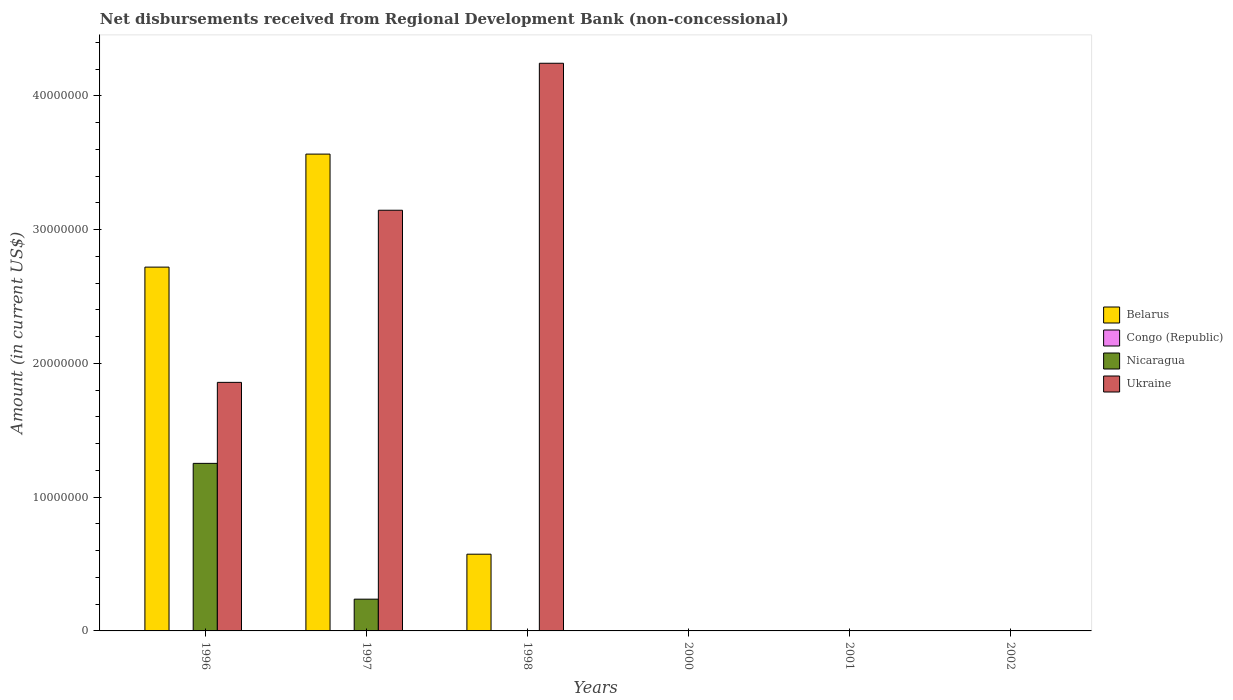How many different coloured bars are there?
Make the answer very short. 3. Are the number of bars on each tick of the X-axis equal?
Your response must be concise. No. How many bars are there on the 5th tick from the left?
Your answer should be compact. 0. What is the label of the 5th group of bars from the left?
Make the answer very short. 2001. What is the amount of disbursements received from Regional Development Bank in Nicaragua in 1996?
Keep it short and to the point. 1.25e+07. Across all years, what is the maximum amount of disbursements received from Regional Development Bank in Ukraine?
Provide a short and direct response. 4.24e+07. Across all years, what is the minimum amount of disbursements received from Regional Development Bank in Nicaragua?
Make the answer very short. 0. In which year was the amount of disbursements received from Regional Development Bank in Belarus maximum?
Give a very brief answer. 1997. What is the total amount of disbursements received from Regional Development Bank in Congo (Republic) in the graph?
Provide a succinct answer. 0. What is the difference between the amount of disbursements received from Regional Development Bank in Nicaragua in 2001 and the amount of disbursements received from Regional Development Bank in Ukraine in 1996?
Ensure brevity in your answer.  -1.86e+07. What is the average amount of disbursements received from Regional Development Bank in Ukraine per year?
Your response must be concise. 1.54e+07. In the year 1997, what is the difference between the amount of disbursements received from Regional Development Bank in Ukraine and amount of disbursements received from Regional Development Bank in Nicaragua?
Ensure brevity in your answer.  2.91e+07. What is the difference between the highest and the second highest amount of disbursements received from Regional Development Bank in Belarus?
Keep it short and to the point. 8.45e+06. What is the difference between the highest and the lowest amount of disbursements received from Regional Development Bank in Nicaragua?
Make the answer very short. 1.25e+07. Is it the case that in every year, the sum of the amount of disbursements received from Regional Development Bank in Ukraine and amount of disbursements received from Regional Development Bank in Congo (Republic) is greater than the amount of disbursements received from Regional Development Bank in Nicaragua?
Your answer should be very brief. No. Are all the bars in the graph horizontal?
Provide a succinct answer. No. How many years are there in the graph?
Your answer should be very brief. 6. Are the values on the major ticks of Y-axis written in scientific E-notation?
Provide a short and direct response. No. Does the graph contain any zero values?
Your answer should be very brief. Yes. Where does the legend appear in the graph?
Provide a succinct answer. Center right. How many legend labels are there?
Make the answer very short. 4. What is the title of the graph?
Your answer should be compact. Net disbursements received from Regional Development Bank (non-concessional). Does "Honduras" appear as one of the legend labels in the graph?
Keep it short and to the point. No. What is the label or title of the X-axis?
Give a very brief answer. Years. What is the label or title of the Y-axis?
Offer a terse response. Amount (in current US$). What is the Amount (in current US$) in Belarus in 1996?
Offer a very short reply. 2.72e+07. What is the Amount (in current US$) of Congo (Republic) in 1996?
Your answer should be compact. 0. What is the Amount (in current US$) in Nicaragua in 1996?
Keep it short and to the point. 1.25e+07. What is the Amount (in current US$) of Ukraine in 1996?
Your answer should be compact. 1.86e+07. What is the Amount (in current US$) in Belarus in 1997?
Your answer should be very brief. 3.56e+07. What is the Amount (in current US$) in Nicaragua in 1997?
Give a very brief answer. 2.37e+06. What is the Amount (in current US$) in Ukraine in 1997?
Your answer should be compact. 3.15e+07. What is the Amount (in current US$) in Belarus in 1998?
Your answer should be very brief. 5.74e+06. What is the Amount (in current US$) in Nicaragua in 1998?
Provide a short and direct response. 0. What is the Amount (in current US$) in Ukraine in 1998?
Keep it short and to the point. 4.24e+07. What is the Amount (in current US$) in Belarus in 2000?
Keep it short and to the point. 0. What is the Amount (in current US$) of Nicaragua in 2000?
Offer a very short reply. 0. What is the Amount (in current US$) in Congo (Republic) in 2001?
Give a very brief answer. 0. What is the Amount (in current US$) in Nicaragua in 2001?
Provide a succinct answer. 0. What is the Amount (in current US$) in Congo (Republic) in 2002?
Offer a very short reply. 0. What is the Amount (in current US$) in Ukraine in 2002?
Provide a succinct answer. 0. Across all years, what is the maximum Amount (in current US$) of Belarus?
Provide a succinct answer. 3.56e+07. Across all years, what is the maximum Amount (in current US$) in Nicaragua?
Give a very brief answer. 1.25e+07. Across all years, what is the maximum Amount (in current US$) of Ukraine?
Your response must be concise. 4.24e+07. Across all years, what is the minimum Amount (in current US$) in Nicaragua?
Your response must be concise. 0. Across all years, what is the minimum Amount (in current US$) in Ukraine?
Make the answer very short. 0. What is the total Amount (in current US$) in Belarus in the graph?
Your response must be concise. 6.86e+07. What is the total Amount (in current US$) in Nicaragua in the graph?
Give a very brief answer. 1.49e+07. What is the total Amount (in current US$) in Ukraine in the graph?
Your response must be concise. 9.25e+07. What is the difference between the Amount (in current US$) of Belarus in 1996 and that in 1997?
Offer a very short reply. -8.45e+06. What is the difference between the Amount (in current US$) in Nicaragua in 1996 and that in 1997?
Ensure brevity in your answer.  1.02e+07. What is the difference between the Amount (in current US$) of Ukraine in 1996 and that in 1997?
Give a very brief answer. -1.29e+07. What is the difference between the Amount (in current US$) of Belarus in 1996 and that in 1998?
Provide a succinct answer. 2.15e+07. What is the difference between the Amount (in current US$) in Ukraine in 1996 and that in 1998?
Keep it short and to the point. -2.39e+07. What is the difference between the Amount (in current US$) of Belarus in 1997 and that in 1998?
Ensure brevity in your answer.  2.99e+07. What is the difference between the Amount (in current US$) of Ukraine in 1997 and that in 1998?
Give a very brief answer. -1.10e+07. What is the difference between the Amount (in current US$) of Belarus in 1996 and the Amount (in current US$) of Nicaragua in 1997?
Offer a very short reply. 2.48e+07. What is the difference between the Amount (in current US$) in Belarus in 1996 and the Amount (in current US$) in Ukraine in 1997?
Keep it short and to the point. -4.25e+06. What is the difference between the Amount (in current US$) of Nicaragua in 1996 and the Amount (in current US$) of Ukraine in 1997?
Offer a very short reply. -1.89e+07. What is the difference between the Amount (in current US$) of Belarus in 1996 and the Amount (in current US$) of Ukraine in 1998?
Offer a very short reply. -1.52e+07. What is the difference between the Amount (in current US$) of Nicaragua in 1996 and the Amount (in current US$) of Ukraine in 1998?
Offer a terse response. -2.99e+07. What is the difference between the Amount (in current US$) of Belarus in 1997 and the Amount (in current US$) of Ukraine in 1998?
Ensure brevity in your answer.  -6.79e+06. What is the difference between the Amount (in current US$) in Nicaragua in 1997 and the Amount (in current US$) in Ukraine in 1998?
Offer a terse response. -4.01e+07. What is the average Amount (in current US$) in Belarus per year?
Give a very brief answer. 1.14e+07. What is the average Amount (in current US$) in Congo (Republic) per year?
Your answer should be very brief. 0. What is the average Amount (in current US$) in Nicaragua per year?
Keep it short and to the point. 2.48e+06. What is the average Amount (in current US$) in Ukraine per year?
Keep it short and to the point. 1.54e+07. In the year 1996, what is the difference between the Amount (in current US$) in Belarus and Amount (in current US$) in Nicaragua?
Provide a short and direct response. 1.47e+07. In the year 1996, what is the difference between the Amount (in current US$) in Belarus and Amount (in current US$) in Ukraine?
Ensure brevity in your answer.  8.62e+06. In the year 1996, what is the difference between the Amount (in current US$) of Nicaragua and Amount (in current US$) of Ukraine?
Give a very brief answer. -6.06e+06. In the year 1997, what is the difference between the Amount (in current US$) of Belarus and Amount (in current US$) of Nicaragua?
Offer a very short reply. 3.33e+07. In the year 1997, what is the difference between the Amount (in current US$) of Belarus and Amount (in current US$) of Ukraine?
Make the answer very short. 4.20e+06. In the year 1997, what is the difference between the Amount (in current US$) in Nicaragua and Amount (in current US$) in Ukraine?
Provide a short and direct response. -2.91e+07. In the year 1998, what is the difference between the Amount (in current US$) in Belarus and Amount (in current US$) in Ukraine?
Your response must be concise. -3.67e+07. What is the ratio of the Amount (in current US$) in Belarus in 1996 to that in 1997?
Keep it short and to the point. 0.76. What is the ratio of the Amount (in current US$) in Nicaragua in 1996 to that in 1997?
Provide a succinct answer. 5.28. What is the ratio of the Amount (in current US$) of Ukraine in 1996 to that in 1997?
Ensure brevity in your answer.  0.59. What is the ratio of the Amount (in current US$) of Belarus in 1996 to that in 1998?
Ensure brevity in your answer.  4.74. What is the ratio of the Amount (in current US$) of Ukraine in 1996 to that in 1998?
Offer a very short reply. 0.44. What is the ratio of the Amount (in current US$) in Belarus in 1997 to that in 1998?
Give a very brief answer. 6.22. What is the ratio of the Amount (in current US$) of Ukraine in 1997 to that in 1998?
Provide a succinct answer. 0.74. What is the difference between the highest and the second highest Amount (in current US$) of Belarus?
Your answer should be compact. 8.45e+06. What is the difference between the highest and the second highest Amount (in current US$) in Ukraine?
Provide a short and direct response. 1.10e+07. What is the difference between the highest and the lowest Amount (in current US$) of Belarus?
Keep it short and to the point. 3.56e+07. What is the difference between the highest and the lowest Amount (in current US$) of Nicaragua?
Provide a succinct answer. 1.25e+07. What is the difference between the highest and the lowest Amount (in current US$) in Ukraine?
Provide a short and direct response. 4.24e+07. 